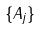<formula> <loc_0><loc_0><loc_500><loc_500>\{ A _ { j } \}</formula> 